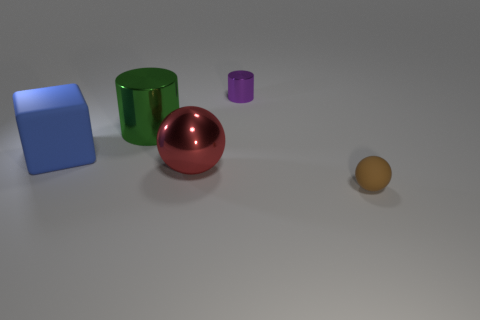What might be the purpose of this arrangement? This image seems to be set up as a demonstration of geometric shapes and the way different surface materials interact with light. The objects are positioned deliberately to display contrasts—between matte and reflective surfaces, as well as the various geometric forms like cubes, cylinders, and spheres. 